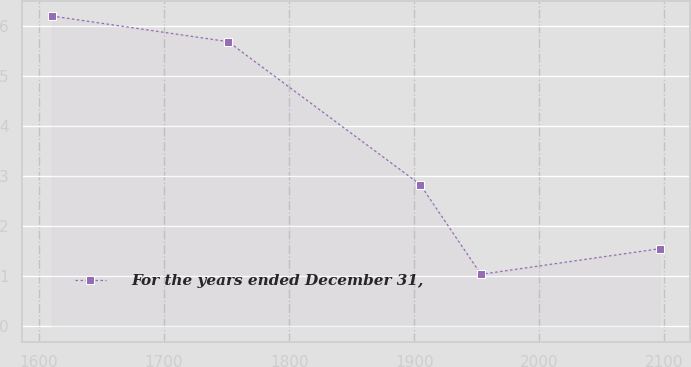Convert chart. <chart><loc_0><loc_0><loc_500><loc_500><line_chart><ecel><fcel>For the years ended December 31,<nl><fcel>1610.52<fcel>6.19<nl><fcel>1751.24<fcel>5.68<nl><fcel>1904.83<fcel>2.83<nl><fcel>1953.4<fcel>1.04<nl><fcel>2096.22<fcel>1.55<nl></chart> 